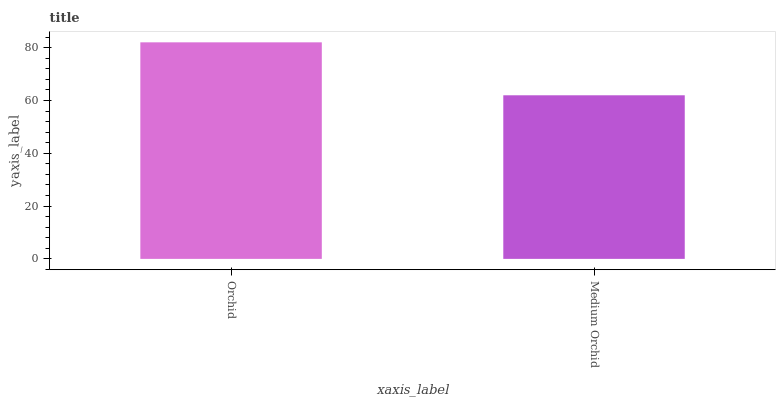Is Medium Orchid the minimum?
Answer yes or no. Yes. Is Orchid the maximum?
Answer yes or no. Yes. Is Medium Orchid the maximum?
Answer yes or no. No. Is Orchid greater than Medium Orchid?
Answer yes or no. Yes. Is Medium Orchid less than Orchid?
Answer yes or no. Yes. Is Medium Orchid greater than Orchid?
Answer yes or no. No. Is Orchid less than Medium Orchid?
Answer yes or no. No. Is Orchid the high median?
Answer yes or no. Yes. Is Medium Orchid the low median?
Answer yes or no. Yes. Is Medium Orchid the high median?
Answer yes or no. No. Is Orchid the low median?
Answer yes or no. No. 